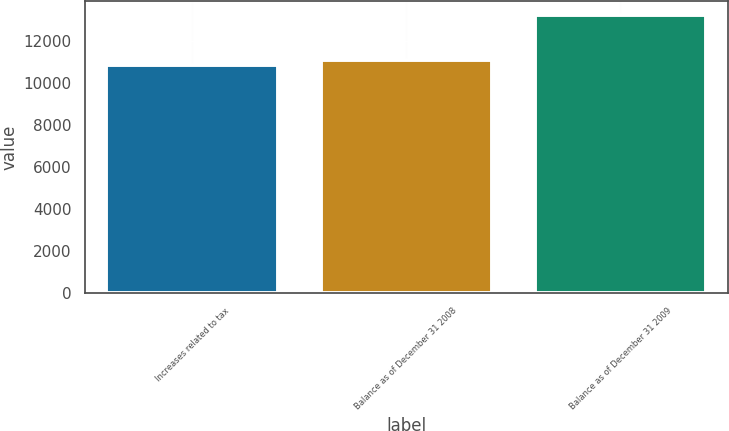Convert chart. <chart><loc_0><loc_0><loc_500><loc_500><bar_chart><fcel>Increases related to tax<fcel>Balance as of December 31 2008<fcel>Balance as of December 31 2009<nl><fcel>10859<fcel>11097.5<fcel>13244<nl></chart> 